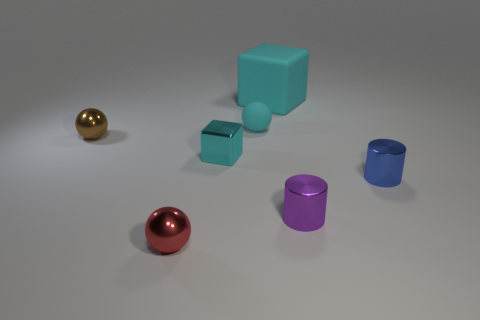Is the small purple object made of the same material as the cyan object to the left of the tiny cyan rubber ball?
Ensure brevity in your answer.  Yes. How many objects are either tiny shiny blocks or large red matte cylinders?
Your response must be concise. 1. Does the cyan block that is in front of the large block have the same size as the ball that is in front of the brown sphere?
Offer a very short reply. Yes. How many cylinders are tiny cyan objects or blue objects?
Make the answer very short. 1. Are any small yellow things visible?
Make the answer very short. No. Are there any other things that are the same shape as the red object?
Your answer should be compact. Yes. Do the tiny rubber thing and the big object have the same color?
Your answer should be compact. Yes. How many objects are tiny cyan objects that are on the left side of the cyan sphere or large green rubber cubes?
Offer a terse response. 1. There is a block that is in front of the small shiny ball that is behind the purple metallic cylinder; how many metal cylinders are to the left of it?
Give a very brief answer. 0. Are there any other things that are the same size as the cyan matte sphere?
Offer a very short reply. Yes. 